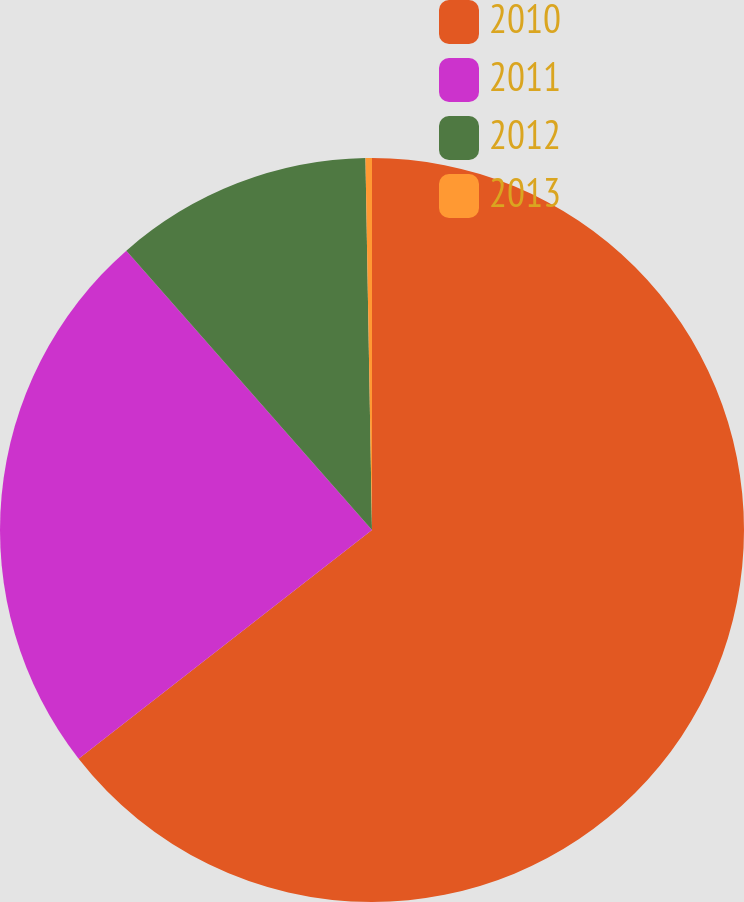Convert chart. <chart><loc_0><loc_0><loc_500><loc_500><pie_chart><fcel>2010<fcel>2011<fcel>2012<fcel>2013<nl><fcel>64.46%<fcel>24.06%<fcel>11.2%<fcel>0.28%<nl></chart> 